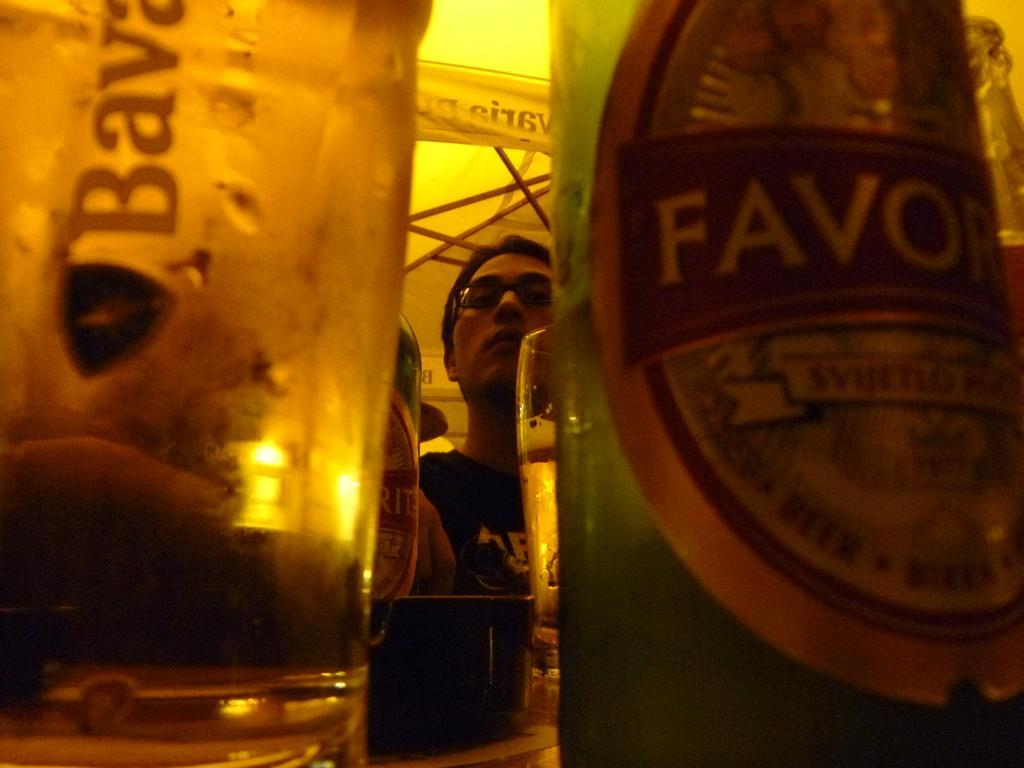Can you describe this image briefly? In this picture there are two glasses and two bottles. There is a glass towards the left and there is a bottle towards the right. In between them there is a man, he is wearing a black t shirt and spectacles. In the top there is a banner and some text written on it. 